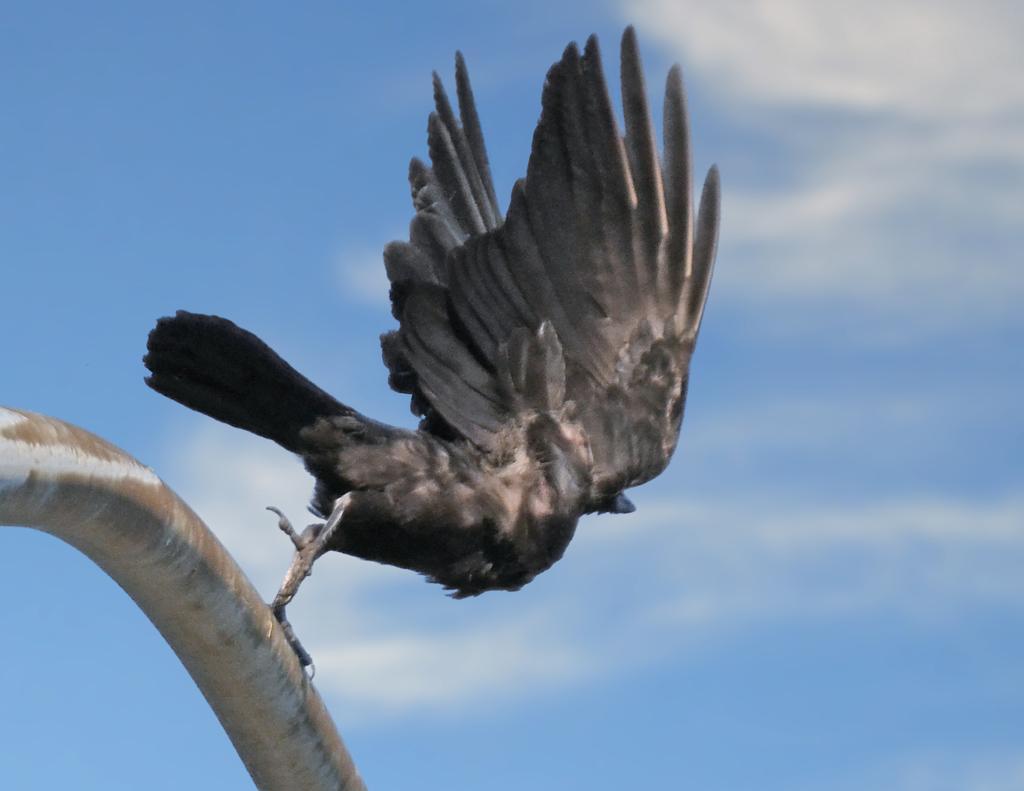Could you give a brief overview of what you see in this image? In this picture I can see a bird is trying to fly it is in grey color, on the left side there is an iron rod. At the top it is the blue color sky. 